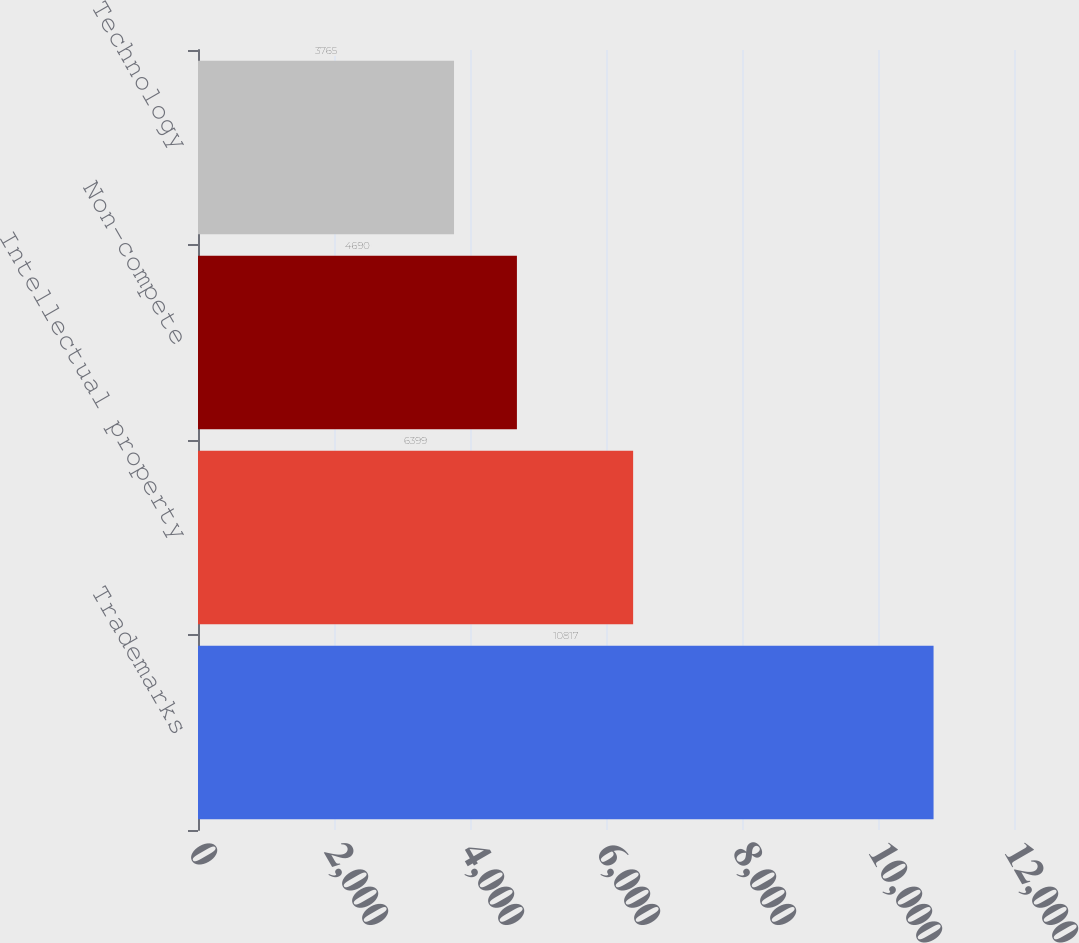Convert chart. <chart><loc_0><loc_0><loc_500><loc_500><bar_chart><fcel>Trademarks<fcel>Intellectual property<fcel>Non-compete<fcel>Technology<nl><fcel>10817<fcel>6399<fcel>4690<fcel>3765<nl></chart> 